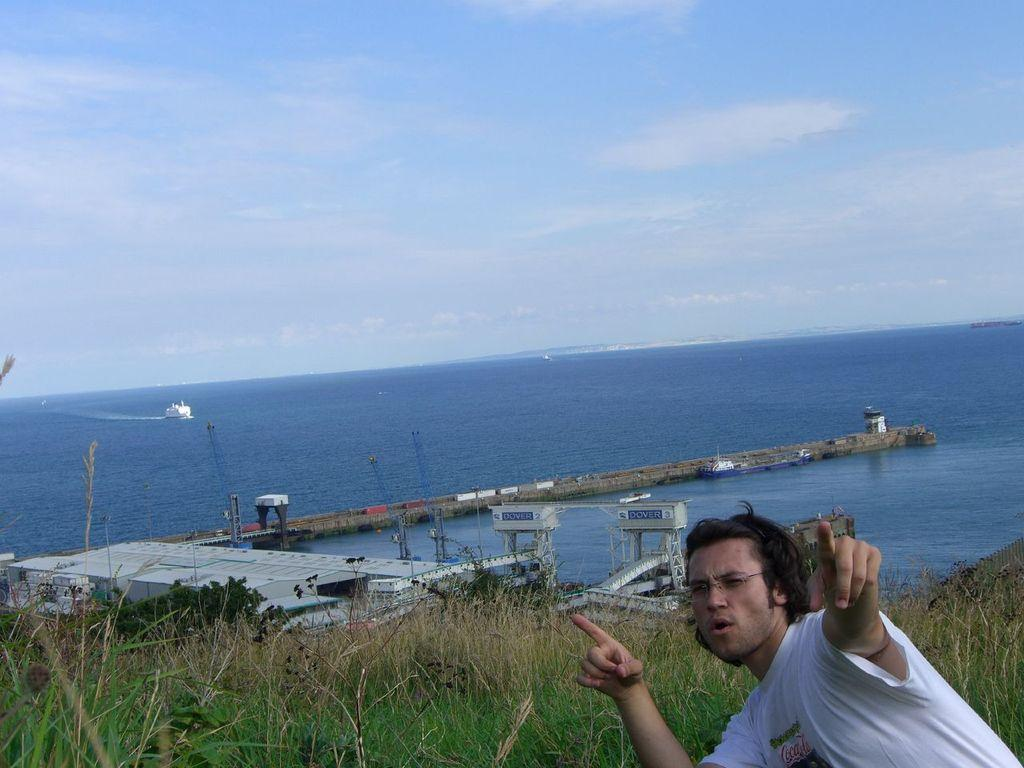What is the man in the image wearing on his face? The man in the image is wearing spectacles. What type of natural environment is visible in the image? There is grass, trees, and a pier in the image, which suggests a natural environment. What type of structure is present in the image? There is a building in the image. What is on the water in the image? There is a ship on the water in the image. What can be seen in the background of the image? The sky is visible in the background of the image. What type of thrill ride can be seen in the image? There is no thrill ride present in the image; it features a man with spectacles, a natural environment, a building, a ship on the water, and a sky visible in the background. 